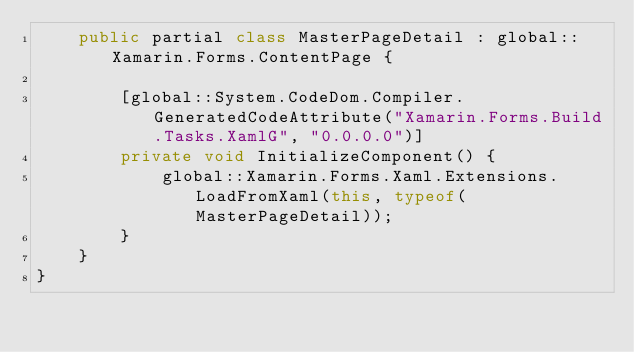Convert code to text. <code><loc_0><loc_0><loc_500><loc_500><_C#_>    public partial class MasterPageDetail : global::Xamarin.Forms.ContentPage {
        
        [global::System.CodeDom.Compiler.GeneratedCodeAttribute("Xamarin.Forms.Build.Tasks.XamlG", "0.0.0.0")]
        private void InitializeComponent() {
            global::Xamarin.Forms.Xaml.Extensions.LoadFromXaml(this, typeof(MasterPageDetail));
        }
    }
}
</code> 